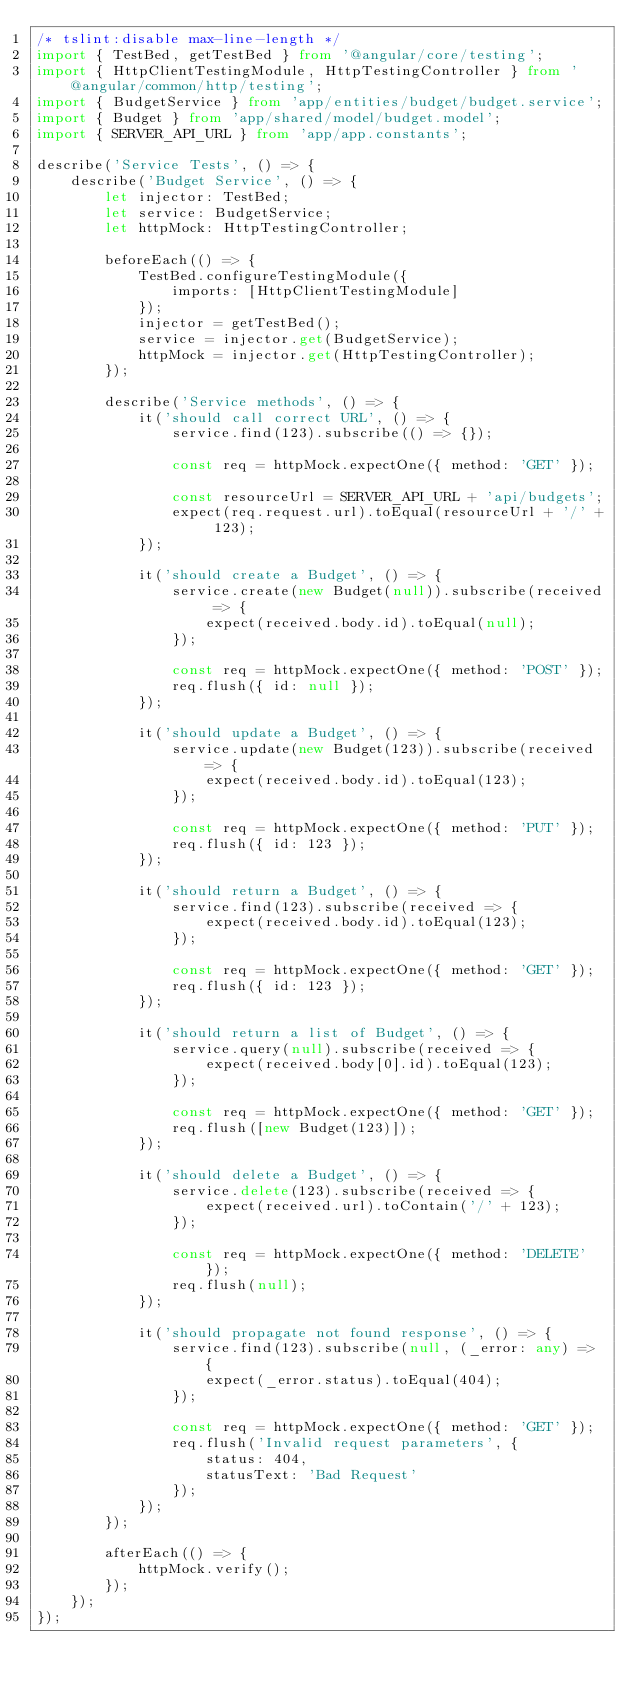Convert code to text. <code><loc_0><loc_0><loc_500><loc_500><_TypeScript_>/* tslint:disable max-line-length */
import { TestBed, getTestBed } from '@angular/core/testing';
import { HttpClientTestingModule, HttpTestingController } from '@angular/common/http/testing';
import { BudgetService } from 'app/entities/budget/budget.service';
import { Budget } from 'app/shared/model/budget.model';
import { SERVER_API_URL } from 'app/app.constants';

describe('Service Tests', () => {
    describe('Budget Service', () => {
        let injector: TestBed;
        let service: BudgetService;
        let httpMock: HttpTestingController;

        beforeEach(() => {
            TestBed.configureTestingModule({
                imports: [HttpClientTestingModule]
            });
            injector = getTestBed();
            service = injector.get(BudgetService);
            httpMock = injector.get(HttpTestingController);
        });

        describe('Service methods', () => {
            it('should call correct URL', () => {
                service.find(123).subscribe(() => {});

                const req = httpMock.expectOne({ method: 'GET' });

                const resourceUrl = SERVER_API_URL + 'api/budgets';
                expect(req.request.url).toEqual(resourceUrl + '/' + 123);
            });

            it('should create a Budget', () => {
                service.create(new Budget(null)).subscribe(received => {
                    expect(received.body.id).toEqual(null);
                });

                const req = httpMock.expectOne({ method: 'POST' });
                req.flush({ id: null });
            });

            it('should update a Budget', () => {
                service.update(new Budget(123)).subscribe(received => {
                    expect(received.body.id).toEqual(123);
                });

                const req = httpMock.expectOne({ method: 'PUT' });
                req.flush({ id: 123 });
            });

            it('should return a Budget', () => {
                service.find(123).subscribe(received => {
                    expect(received.body.id).toEqual(123);
                });

                const req = httpMock.expectOne({ method: 'GET' });
                req.flush({ id: 123 });
            });

            it('should return a list of Budget', () => {
                service.query(null).subscribe(received => {
                    expect(received.body[0].id).toEqual(123);
                });

                const req = httpMock.expectOne({ method: 'GET' });
                req.flush([new Budget(123)]);
            });

            it('should delete a Budget', () => {
                service.delete(123).subscribe(received => {
                    expect(received.url).toContain('/' + 123);
                });

                const req = httpMock.expectOne({ method: 'DELETE' });
                req.flush(null);
            });

            it('should propagate not found response', () => {
                service.find(123).subscribe(null, (_error: any) => {
                    expect(_error.status).toEqual(404);
                });

                const req = httpMock.expectOne({ method: 'GET' });
                req.flush('Invalid request parameters', {
                    status: 404,
                    statusText: 'Bad Request'
                });
            });
        });

        afterEach(() => {
            httpMock.verify();
        });
    });
});
</code> 